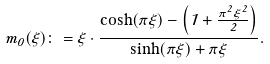<formula> <loc_0><loc_0><loc_500><loc_500>m _ { 0 } ( \xi ) \colon = \xi \cdot \frac { \cosh ( \pi \xi ) - \left ( 1 + \frac { \pi ^ { 2 } \xi ^ { 2 } } { 2 } \right ) } { \sinh ( \pi \xi ) + \pi \xi } .</formula> 